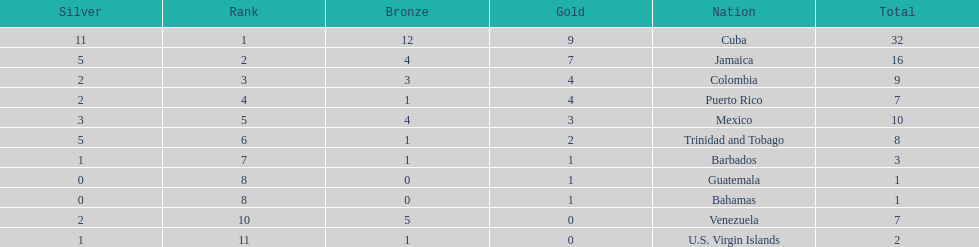Parse the table in full. {'header': ['Silver', 'Rank', 'Bronze', 'Gold', 'Nation', 'Total'], 'rows': [['11', '1', '12', '9', 'Cuba', '32'], ['5', '2', '4', '7', 'Jamaica', '16'], ['2', '3', '3', '4', 'Colombia', '9'], ['2', '4', '1', '4', 'Puerto Rico', '7'], ['3', '5', '4', '3', 'Mexico', '10'], ['5', '6', '1', '2', 'Trinidad and Tobago', '8'], ['1', '7', '1', '1', 'Barbados', '3'], ['0', '8', '0', '1', 'Guatemala', '1'], ['0', '8', '0', '1', 'Bahamas', '1'], ['2', '10', '5', '0', 'Venezuela', '7'], ['1', '11', '1', '0', 'U.S. Virgin Islands', '2']]} The nation before mexico in the table Puerto Rico. 